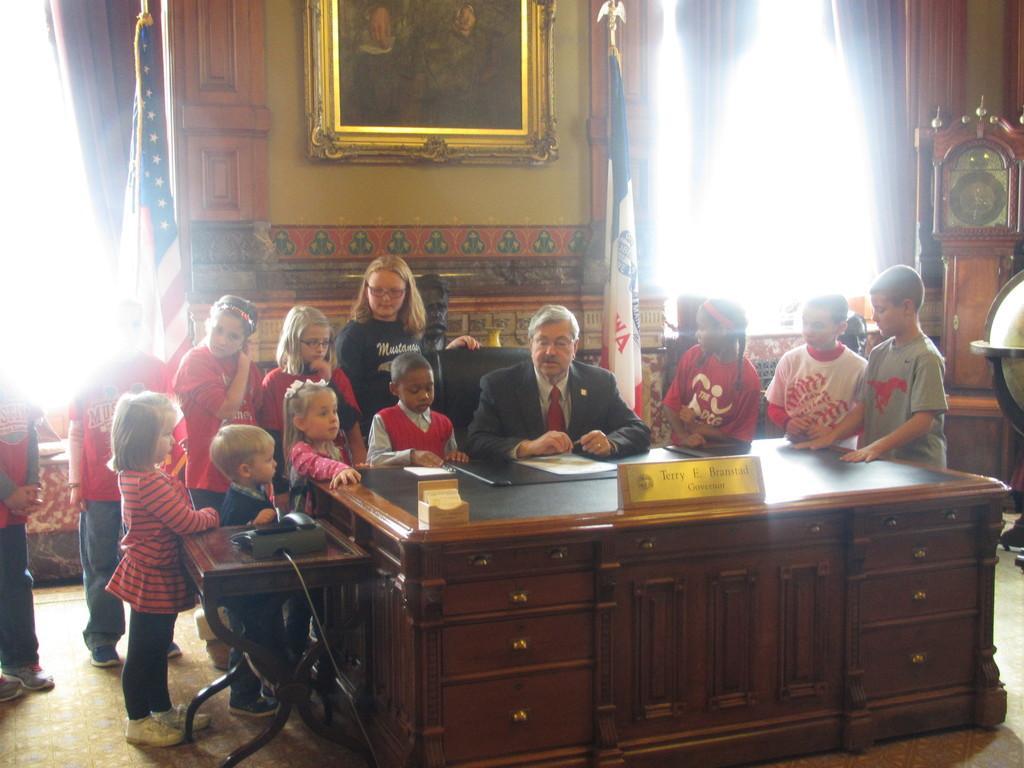Can you describe this image briefly? In this image I can see a man is sitting on a chair and here I can see number of children. In the background I can see two flags, a frame on this wall and here I can see a clock. 